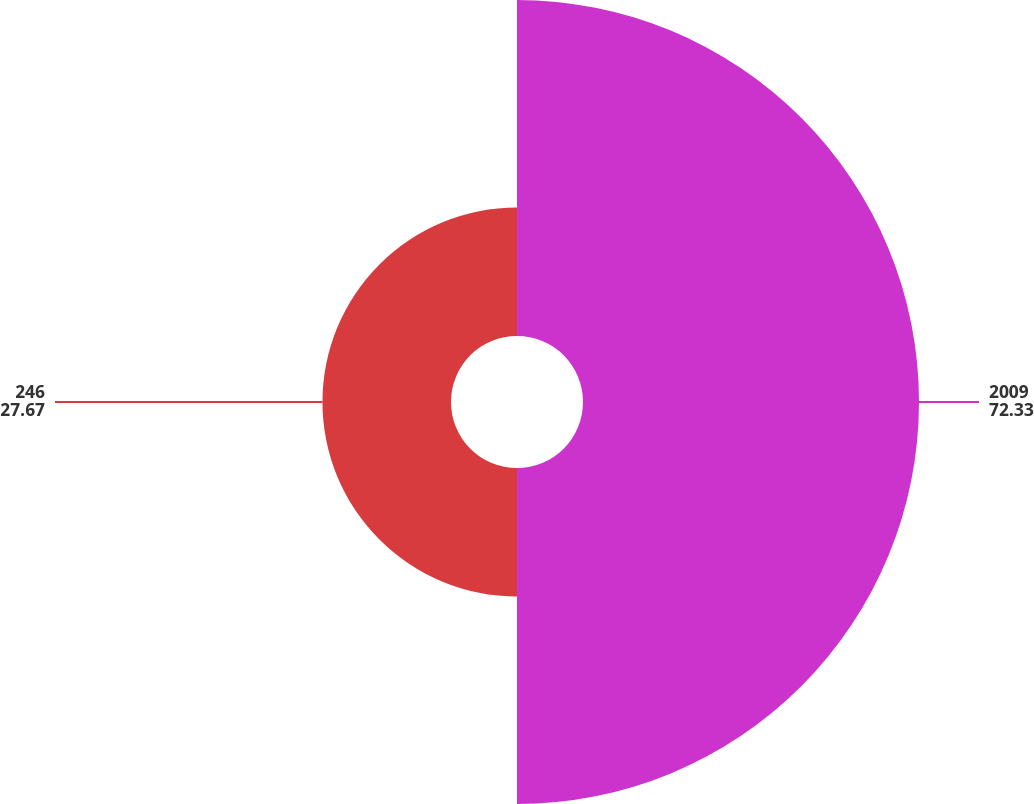<chart> <loc_0><loc_0><loc_500><loc_500><pie_chart><fcel>2009<fcel>246<nl><fcel>72.33%<fcel>27.67%<nl></chart> 